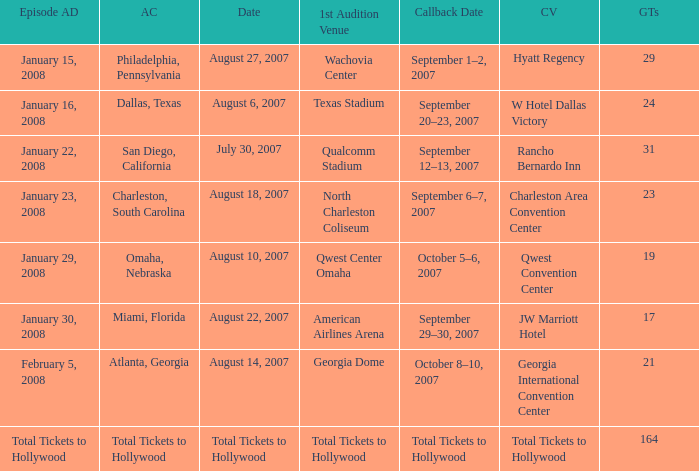How many golden tickets for the georgia international convention center? 21.0. 